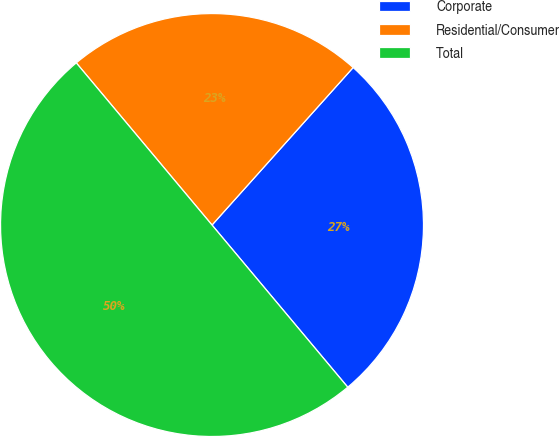Convert chart. <chart><loc_0><loc_0><loc_500><loc_500><pie_chart><fcel>Corporate<fcel>Residential/Consumer<fcel>Total<nl><fcel>27.28%<fcel>22.72%<fcel>50.0%<nl></chart> 